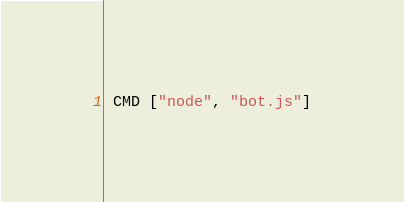<code> <loc_0><loc_0><loc_500><loc_500><_Dockerfile_> CMD ["node", "bot.js"]</code> 